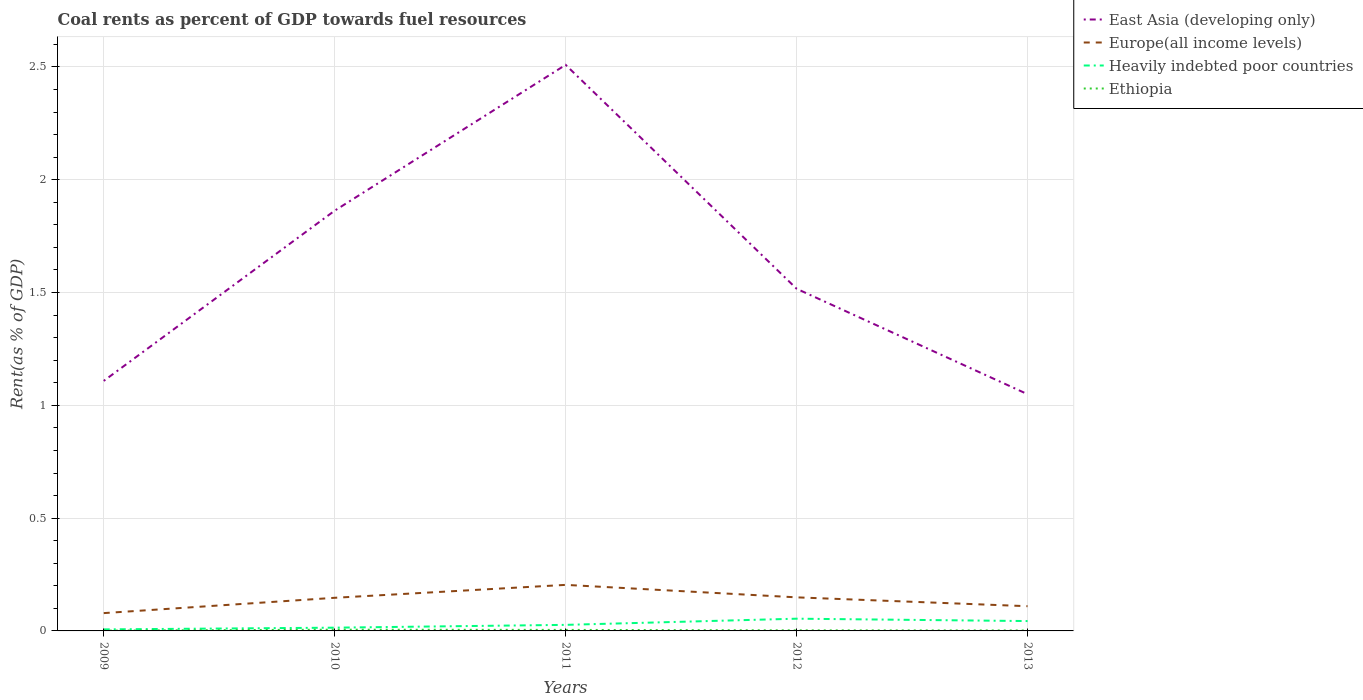Does the line corresponding to East Asia (developing only) intersect with the line corresponding to Heavily indebted poor countries?
Your answer should be compact. No. Is the number of lines equal to the number of legend labels?
Give a very brief answer. Yes. Across all years, what is the maximum coal rent in Europe(all income levels)?
Your answer should be very brief. 0.08. In which year was the coal rent in Ethiopia maximum?
Keep it short and to the point. 2009. What is the total coal rent in Europe(all income levels) in the graph?
Make the answer very short. 0.04. What is the difference between the highest and the second highest coal rent in Heavily indebted poor countries?
Offer a very short reply. 0.05. Are the values on the major ticks of Y-axis written in scientific E-notation?
Provide a succinct answer. No. How many legend labels are there?
Offer a terse response. 4. How are the legend labels stacked?
Offer a terse response. Vertical. What is the title of the graph?
Keep it short and to the point. Coal rents as percent of GDP towards fuel resources. Does "Nigeria" appear as one of the legend labels in the graph?
Ensure brevity in your answer.  No. What is the label or title of the Y-axis?
Make the answer very short. Rent(as % of GDP). What is the Rent(as % of GDP) of East Asia (developing only) in 2009?
Your answer should be compact. 1.11. What is the Rent(as % of GDP) in Europe(all income levels) in 2009?
Provide a short and direct response. 0.08. What is the Rent(as % of GDP) in Heavily indebted poor countries in 2009?
Keep it short and to the point. 0.01. What is the Rent(as % of GDP) in Ethiopia in 2009?
Your response must be concise. 0. What is the Rent(as % of GDP) in East Asia (developing only) in 2010?
Your answer should be very brief. 1.86. What is the Rent(as % of GDP) of Europe(all income levels) in 2010?
Make the answer very short. 0.15. What is the Rent(as % of GDP) of Heavily indebted poor countries in 2010?
Provide a succinct answer. 0.01. What is the Rent(as % of GDP) of Ethiopia in 2010?
Your answer should be compact. 0.01. What is the Rent(as % of GDP) in East Asia (developing only) in 2011?
Offer a terse response. 2.51. What is the Rent(as % of GDP) in Europe(all income levels) in 2011?
Offer a very short reply. 0.2. What is the Rent(as % of GDP) in Heavily indebted poor countries in 2011?
Provide a short and direct response. 0.03. What is the Rent(as % of GDP) of Ethiopia in 2011?
Ensure brevity in your answer.  0. What is the Rent(as % of GDP) of East Asia (developing only) in 2012?
Offer a very short reply. 1.52. What is the Rent(as % of GDP) of Europe(all income levels) in 2012?
Give a very brief answer. 0.15. What is the Rent(as % of GDP) in Heavily indebted poor countries in 2012?
Your answer should be very brief. 0.05. What is the Rent(as % of GDP) of Ethiopia in 2012?
Ensure brevity in your answer.  0. What is the Rent(as % of GDP) in East Asia (developing only) in 2013?
Your answer should be compact. 1.05. What is the Rent(as % of GDP) in Europe(all income levels) in 2013?
Your answer should be very brief. 0.11. What is the Rent(as % of GDP) in Heavily indebted poor countries in 2013?
Provide a short and direct response. 0.04. What is the Rent(as % of GDP) in Ethiopia in 2013?
Provide a succinct answer. 0. Across all years, what is the maximum Rent(as % of GDP) of East Asia (developing only)?
Make the answer very short. 2.51. Across all years, what is the maximum Rent(as % of GDP) in Europe(all income levels)?
Ensure brevity in your answer.  0.2. Across all years, what is the maximum Rent(as % of GDP) in Heavily indebted poor countries?
Keep it short and to the point. 0.05. Across all years, what is the maximum Rent(as % of GDP) of Ethiopia?
Ensure brevity in your answer.  0.01. Across all years, what is the minimum Rent(as % of GDP) in East Asia (developing only)?
Offer a very short reply. 1.05. Across all years, what is the minimum Rent(as % of GDP) in Europe(all income levels)?
Your answer should be compact. 0.08. Across all years, what is the minimum Rent(as % of GDP) of Heavily indebted poor countries?
Your response must be concise. 0.01. Across all years, what is the minimum Rent(as % of GDP) of Ethiopia?
Provide a succinct answer. 0. What is the total Rent(as % of GDP) in East Asia (developing only) in the graph?
Your response must be concise. 8.05. What is the total Rent(as % of GDP) of Europe(all income levels) in the graph?
Offer a very short reply. 0.69. What is the total Rent(as % of GDP) of Heavily indebted poor countries in the graph?
Your response must be concise. 0.15. What is the total Rent(as % of GDP) in Ethiopia in the graph?
Your answer should be compact. 0.02. What is the difference between the Rent(as % of GDP) of East Asia (developing only) in 2009 and that in 2010?
Your answer should be compact. -0.75. What is the difference between the Rent(as % of GDP) in Europe(all income levels) in 2009 and that in 2010?
Offer a terse response. -0.07. What is the difference between the Rent(as % of GDP) in Heavily indebted poor countries in 2009 and that in 2010?
Offer a terse response. -0.01. What is the difference between the Rent(as % of GDP) in Ethiopia in 2009 and that in 2010?
Give a very brief answer. -0. What is the difference between the Rent(as % of GDP) of East Asia (developing only) in 2009 and that in 2011?
Make the answer very short. -1.4. What is the difference between the Rent(as % of GDP) of Europe(all income levels) in 2009 and that in 2011?
Your answer should be very brief. -0.13. What is the difference between the Rent(as % of GDP) in Heavily indebted poor countries in 2009 and that in 2011?
Offer a very short reply. -0.02. What is the difference between the Rent(as % of GDP) in Ethiopia in 2009 and that in 2011?
Give a very brief answer. -0. What is the difference between the Rent(as % of GDP) of East Asia (developing only) in 2009 and that in 2012?
Provide a short and direct response. -0.41. What is the difference between the Rent(as % of GDP) in Europe(all income levels) in 2009 and that in 2012?
Give a very brief answer. -0.07. What is the difference between the Rent(as % of GDP) of Heavily indebted poor countries in 2009 and that in 2012?
Offer a terse response. -0.05. What is the difference between the Rent(as % of GDP) in Ethiopia in 2009 and that in 2012?
Provide a succinct answer. -0. What is the difference between the Rent(as % of GDP) in East Asia (developing only) in 2009 and that in 2013?
Offer a very short reply. 0.06. What is the difference between the Rent(as % of GDP) of Europe(all income levels) in 2009 and that in 2013?
Offer a terse response. -0.03. What is the difference between the Rent(as % of GDP) of Heavily indebted poor countries in 2009 and that in 2013?
Keep it short and to the point. -0.04. What is the difference between the Rent(as % of GDP) in Ethiopia in 2009 and that in 2013?
Keep it short and to the point. -0. What is the difference between the Rent(as % of GDP) in East Asia (developing only) in 2010 and that in 2011?
Offer a very short reply. -0.65. What is the difference between the Rent(as % of GDP) in Europe(all income levels) in 2010 and that in 2011?
Make the answer very short. -0.06. What is the difference between the Rent(as % of GDP) of Heavily indebted poor countries in 2010 and that in 2011?
Offer a very short reply. -0.01. What is the difference between the Rent(as % of GDP) of Ethiopia in 2010 and that in 2011?
Your answer should be very brief. 0. What is the difference between the Rent(as % of GDP) of East Asia (developing only) in 2010 and that in 2012?
Provide a succinct answer. 0.35. What is the difference between the Rent(as % of GDP) in Europe(all income levels) in 2010 and that in 2012?
Make the answer very short. -0. What is the difference between the Rent(as % of GDP) in Heavily indebted poor countries in 2010 and that in 2012?
Your response must be concise. -0.04. What is the difference between the Rent(as % of GDP) in Ethiopia in 2010 and that in 2012?
Your response must be concise. 0. What is the difference between the Rent(as % of GDP) of East Asia (developing only) in 2010 and that in 2013?
Keep it short and to the point. 0.81. What is the difference between the Rent(as % of GDP) in Europe(all income levels) in 2010 and that in 2013?
Provide a short and direct response. 0.04. What is the difference between the Rent(as % of GDP) of Heavily indebted poor countries in 2010 and that in 2013?
Your response must be concise. -0.03. What is the difference between the Rent(as % of GDP) in Ethiopia in 2010 and that in 2013?
Offer a terse response. 0. What is the difference between the Rent(as % of GDP) in Europe(all income levels) in 2011 and that in 2012?
Your answer should be very brief. 0.06. What is the difference between the Rent(as % of GDP) in Heavily indebted poor countries in 2011 and that in 2012?
Your answer should be very brief. -0.03. What is the difference between the Rent(as % of GDP) of Ethiopia in 2011 and that in 2012?
Your answer should be compact. 0. What is the difference between the Rent(as % of GDP) in East Asia (developing only) in 2011 and that in 2013?
Keep it short and to the point. 1.46. What is the difference between the Rent(as % of GDP) in Europe(all income levels) in 2011 and that in 2013?
Provide a short and direct response. 0.09. What is the difference between the Rent(as % of GDP) of Heavily indebted poor countries in 2011 and that in 2013?
Your response must be concise. -0.02. What is the difference between the Rent(as % of GDP) of Ethiopia in 2011 and that in 2013?
Offer a very short reply. 0. What is the difference between the Rent(as % of GDP) in East Asia (developing only) in 2012 and that in 2013?
Your answer should be very brief. 0.47. What is the difference between the Rent(as % of GDP) in Europe(all income levels) in 2012 and that in 2013?
Make the answer very short. 0.04. What is the difference between the Rent(as % of GDP) in Heavily indebted poor countries in 2012 and that in 2013?
Provide a succinct answer. 0.01. What is the difference between the Rent(as % of GDP) of East Asia (developing only) in 2009 and the Rent(as % of GDP) of Europe(all income levels) in 2010?
Make the answer very short. 0.96. What is the difference between the Rent(as % of GDP) in East Asia (developing only) in 2009 and the Rent(as % of GDP) in Heavily indebted poor countries in 2010?
Your answer should be very brief. 1.09. What is the difference between the Rent(as % of GDP) in East Asia (developing only) in 2009 and the Rent(as % of GDP) in Ethiopia in 2010?
Offer a very short reply. 1.1. What is the difference between the Rent(as % of GDP) in Europe(all income levels) in 2009 and the Rent(as % of GDP) in Heavily indebted poor countries in 2010?
Keep it short and to the point. 0.06. What is the difference between the Rent(as % of GDP) in Europe(all income levels) in 2009 and the Rent(as % of GDP) in Ethiopia in 2010?
Your answer should be compact. 0.07. What is the difference between the Rent(as % of GDP) in Heavily indebted poor countries in 2009 and the Rent(as % of GDP) in Ethiopia in 2010?
Provide a succinct answer. 0. What is the difference between the Rent(as % of GDP) in East Asia (developing only) in 2009 and the Rent(as % of GDP) in Europe(all income levels) in 2011?
Your response must be concise. 0.9. What is the difference between the Rent(as % of GDP) of East Asia (developing only) in 2009 and the Rent(as % of GDP) of Heavily indebted poor countries in 2011?
Provide a short and direct response. 1.08. What is the difference between the Rent(as % of GDP) in East Asia (developing only) in 2009 and the Rent(as % of GDP) in Ethiopia in 2011?
Make the answer very short. 1.1. What is the difference between the Rent(as % of GDP) in Europe(all income levels) in 2009 and the Rent(as % of GDP) in Heavily indebted poor countries in 2011?
Give a very brief answer. 0.05. What is the difference between the Rent(as % of GDP) of Europe(all income levels) in 2009 and the Rent(as % of GDP) of Ethiopia in 2011?
Your answer should be very brief. 0.07. What is the difference between the Rent(as % of GDP) of Heavily indebted poor countries in 2009 and the Rent(as % of GDP) of Ethiopia in 2011?
Ensure brevity in your answer.  0. What is the difference between the Rent(as % of GDP) in East Asia (developing only) in 2009 and the Rent(as % of GDP) in Europe(all income levels) in 2012?
Your answer should be very brief. 0.96. What is the difference between the Rent(as % of GDP) in East Asia (developing only) in 2009 and the Rent(as % of GDP) in Heavily indebted poor countries in 2012?
Your answer should be very brief. 1.05. What is the difference between the Rent(as % of GDP) of East Asia (developing only) in 2009 and the Rent(as % of GDP) of Ethiopia in 2012?
Offer a terse response. 1.11. What is the difference between the Rent(as % of GDP) in Europe(all income levels) in 2009 and the Rent(as % of GDP) in Heavily indebted poor countries in 2012?
Give a very brief answer. 0.02. What is the difference between the Rent(as % of GDP) in Europe(all income levels) in 2009 and the Rent(as % of GDP) in Ethiopia in 2012?
Offer a very short reply. 0.08. What is the difference between the Rent(as % of GDP) in Heavily indebted poor countries in 2009 and the Rent(as % of GDP) in Ethiopia in 2012?
Your response must be concise. 0. What is the difference between the Rent(as % of GDP) in East Asia (developing only) in 2009 and the Rent(as % of GDP) in Heavily indebted poor countries in 2013?
Give a very brief answer. 1.06. What is the difference between the Rent(as % of GDP) in East Asia (developing only) in 2009 and the Rent(as % of GDP) in Ethiopia in 2013?
Provide a short and direct response. 1.11. What is the difference between the Rent(as % of GDP) in Europe(all income levels) in 2009 and the Rent(as % of GDP) in Heavily indebted poor countries in 2013?
Ensure brevity in your answer.  0.04. What is the difference between the Rent(as % of GDP) of Europe(all income levels) in 2009 and the Rent(as % of GDP) of Ethiopia in 2013?
Ensure brevity in your answer.  0.08. What is the difference between the Rent(as % of GDP) in Heavily indebted poor countries in 2009 and the Rent(as % of GDP) in Ethiopia in 2013?
Provide a succinct answer. 0. What is the difference between the Rent(as % of GDP) in East Asia (developing only) in 2010 and the Rent(as % of GDP) in Europe(all income levels) in 2011?
Make the answer very short. 1.66. What is the difference between the Rent(as % of GDP) of East Asia (developing only) in 2010 and the Rent(as % of GDP) of Heavily indebted poor countries in 2011?
Keep it short and to the point. 1.84. What is the difference between the Rent(as % of GDP) of East Asia (developing only) in 2010 and the Rent(as % of GDP) of Ethiopia in 2011?
Keep it short and to the point. 1.86. What is the difference between the Rent(as % of GDP) in Europe(all income levels) in 2010 and the Rent(as % of GDP) in Heavily indebted poor countries in 2011?
Provide a short and direct response. 0.12. What is the difference between the Rent(as % of GDP) in Europe(all income levels) in 2010 and the Rent(as % of GDP) in Ethiopia in 2011?
Provide a succinct answer. 0.14. What is the difference between the Rent(as % of GDP) in Heavily indebted poor countries in 2010 and the Rent(as % of GDP) in Ethiopia in 2011?
Keep it short and to the point. 0.01. What is the difference between the Rent(as % of GDP) of East Asia (developing only) in 2010 and the Rent(as % of GDP) of Europe(all income levels) in 2012?
Offer a very short reply. 1.71. What is the difference between the Rent(as % of GDP) of East Asia (developing only) in 2010 and the Rent(as % of GDP) of Heavily indebted poor countries in 2012?
Give a very brief answer. 1.81. What is the difference between the Rent(as % of GDP) in East Asia (developing only) in 2010 and the Rent(as % of GDP) in Ethiopia in 2012?
Offer a terse response. 1.86. What is the difference between the Rent(as % of GDP) in Europe(all income levels) in 2010 and the Rent(as % of GDP) in Heavily indebted poor countries in 2012?
Offer a terse response. 0.09. What is the difference between the Rent(as % of GDP) of Europe(all income levels) in 2010 and the Rent(as % of GDP) of Ethiopia in 2012?
Offer a very short reply. 0.14. What is the difference between the Rent(as % of GDP) in Heavily indebted poor countries in 2010 and the Rent(as % of GDP) in Ethiopia in 2012?
Give a very brief answer. 0.01. What is the difference between the Rent(as % of GDP) in East Asia (developing only) in 2010 and the Rent(as % of GDP) in Europe(all income levels) in 2013?
Offer a very short reply. 1.75. What is the difference between the Rent(as % of GDP) in East Asia (developing only) in 2010 and the Rent(as % of GDP) in Heavily indebted poor countries in 2013?
Provide a succinct answer. 1.82. What is the difference between the Rent(as % of GDP) of East Asia (developing only) in 2010 and the Rent(as % of GDP) of Ethiopia in 2013?
Ensure brevity in your answer.  1.86. What is the difference between the Rent(as % of GDP) of Europe(all income levels) in 2010 and the Rent(as % of GDP) of Heavily indebted poor countries in 2013?
Keep it short and to the point. 0.1. What is the difference between the Rent(as % of GDP) in Europe(all income levels) in 2010 and the Rent(as % of GDP) in Ethiopia in 2013?
Your response must be concise. 0.14. What is the difference between the Rent(as % of GDP) of Heavily indebted poor countries in 2010 and the Rent(as % of GDP) of Ethiopia in 2013?
Provide a succinct answer. 0.01. What is the difference between the Rent(as % of GDP) of East Asia (developing only) in 2011 and the Rent(as % of GDP) of Europe(all income levels) in 2012?
Give a very brief answer. 2.36. What is the difference between the Rent(as % of GDP) of East Asia (developing only) in 2011 and the Rent(as % of GDP) of Heavily indebted poor countries in 2012?
Keep it short and to the point. 2.45. What is the difference between the Rent(as % of GDP) in East Asia (developing only) in 2011 and the Rent(as % of GDP) in Ethiopia in 2012?
Ensure brevity in your answer.  2.51. What is the difference between the Rent(as % of GDP) in Europe(all income levels) in 2011 and the Rent(as % of GDP) in Heavily indebted poor countries in 2012?
Your answer should be compact. 0.15. What is the difference between the Rent(as % of GDP) in Europe(all income levels) in 2011 and the Rent(as % of GDP) in Ethiopia in 2012?
Provide a succinct answer. 0.2. What is the difference between the Rent(as % of GDP) in Heavily indebted poor countries in 2011 and the Rent(as % of GDP) in Ethiopia in 2012?
Provide a short and direct response. 0.02. What is the difference between the Rent(as % of GDP) of East Asia (developing only) in 2011 and the Rent(as % of GDP) of Europe(all income levels) in 2013?
Your answer should be compact. 2.4. What is the difference between the Rent(as % of GDP) in East Asia (developing only) in 2011 and the Rent(as % of GDP) in Heavily indebted poor countries in 2013?
Your answer should be compact. 2.47. What is the difference between the Rent(as % of GDP) in East Asia (developing only) in 2011 and the Rent(as % of GDP) in Ethiopia in 2013?
Ensure brevity in your answer.  2.51. What is the difference between the Rent(as % of GDP) in Europe(all income levels) in 2011 and the Rent(as % of GDP) in Heavily indebted poor countries in 2013?
Provide a succinct answer. 0.16. What is the difference between the Rent(as % of GDP) of Europe(all income levels) in 2011 and the Rent(as % of GDP) of Ethiopia in 2013?
Provide a succinct answer. 0.2. What is the difference between the Rent(as % of GDP) of Heavily indebted poor countries in 2011 and the Rent(as % of GDP) of Ethiopia in 2013?
Give a very brief answer. 0.02. What is the difference between the Rent(as % of GDP) of East Asia (developing only) in 2012 and the Rent(as % of GDP) of Europe(all income levels) in 2013?
Provide a succinct answer. 1.41. What is the difference between the Rent(as % of GDP) in East Asia (developing only) in 2012 and the Rent(as % of GDP) in Heavily indebted poor countries in 2013?
Keep it short and to the point. 1.47. What is the difference between the Rent(as % of GDP) of East Asia (developing only) in 2012 and the Rent(as % of GDP) of Ethiopia in 2013?
Offer a terse response. 1.51. What is the difference between the Rent(as % of GDP) of Europe(all income levels) in 2012 and the Rent(as % of GDP) of Heavily indebted poor countries in 2013?
Your response must be concise. 0.11. What is the difference between the Rent(as % of GDP) of Europe(all income levels) in 2012 and the Rent(as % of GDP) of Ethiopia in 2013?
Ensure brevity in your answer.  0.15. What is the difference between the Rent(as % of GDP) in Heavily indebted poor countries in 2012 and the Rent(as % of GDP) in Ethiopia in 2013?
Offer a very short reply. 0.05. What is the average Rent(as % of GDP) in East Asia (developing only) per year?
Give a very brief answer. 1.61. What is the average Rent(as % of GDP) of Europe(all income levels) per year?
Keep it short and to the point. 0.14. What is the average Rent(as % of GDP) in Heavily indebted poor countries per year?
Provide a succinct answer. 0.03. What is the average Rent(as % of GDP) in Ethiopia per year?
Keep it short and to the point. 0. In the year 2009, what is the difference between the Rent(as % of GDP) in East Asia (developing only) and Rent(as % of GDP) in Europe(all income levels)?
Your answer should be compact. 1.03. In the year 2009, what is the difference between the Rent(as % of GDP) in East Asia (developing only) and Rent(as % of GDP) in Heavily indebted poor countries?
Your answer should be compact. 1.1. In the year 2009, what is the difference between the Rent(as % of GDP) of East Asia (developing only) and Rent(as % of GDP) of Ethiopia?
Keep it short and to the point. 1.11. In the year 2009, what is the difference between the Rent(as % of GDP) of Europe(all income levels) and Rent(as % of GDP) of Heavily indebted poor countries?
Your response must be concise. 0.07. In the year 2009, what is the difference between the Rent(as % of GDP) in Europe(all income levels) and Rent(as % of GDP) in Ethiopia?
Offer a very short reply. 0.08. In the year 2009, what is the difference between the Rent(as % of GDP) in Heavily indebted poor countries and Rent(as % of GDP) in Ethiopia?
Provide a succinct answer. 0.01. In the year 2010, what is the difference between the Rent(as % of GDP) of East Asia (developing only) and Rent(as % of GDP) of Europe(all income levels)?
Make the answer very short. 1.72. In the year 2010, what is the difference between the Rent(as % of GDP) of East Asia (developing only) and Rent(as % of GDP) of Heavily indebted poor countries?
Your response must be concise. 1.85. In the year 2010, what is the difference between the Rent(as % of GDP) in East Asia (developing only) and Rent(as % of GDP) in Ethiopia?
Offer a terse response. 1.86. In the year 2010, what is the difference between the Rent(as % of GDP) of Europe(all income levels) and Rent(as % of GDP) of Heavily indebted poor countries?
Your response must be concise. 0.13. In the year 2010, what is the difference between the Rent(as % of GDP) in Europe(all income levels) and Rent(as % of GDP) in Ethiopia?
Offer a terse response. 0.14. In the year 2010, what is the difference between the Rent(as % of GDP) in Heavily indebted poor countries and Rent(as % of GDP) in Ethiopia?
Provide a short and direct response. 0.01. In the year 2011, what is the difference between the Rent(as % of GDP) in East Asia (developing only) and Rent(as % of GDP) in Europe(all income levels)?
Ensure brevity in your answer.  2.31. In the year 2011, what is the difference between the Rent(as % of GDP) of East Asia (developing only) and Rent(as % of GDP) of Heavily indebted poor countries?
Offer a very short reply. 2.48. In the year 2011, what is the difference between the Rent(as % of GDP) of East Asia (developing only) and Rent(as % of GDP) of Ethiopia?
Make the answer very short. 2.5. In the year 2011, what is the difference between the Rent(as % of GDP) of Europe(all income levels) and Rent(as % of GDP) of Heavily indebted poor countries?
Keep it short and to the point. 0.18. In the year 2011, what is the difference between the Rent(as % of GDP) of Europe(all income levels) and Rent(as % of GDP) of Ethiopia?
Offer a terse response. 0.2. In the year 2011, what is the difference between the Rent(as % of GDP) in Heavily indebted poor countries and Rent(as % of GDP) in Ethiopia?
Make the answer very short. 0.02. In the year 2012, what is the difference between the Rent(as % of GDP) in East Asia (developing only) and Rent(as % of GDP) in Europe(all income levels)?
Make the answer very short. 1.37. In the year 2012, what is the difference between the Rent(as % of GDP) of East Asia (developing only) and Rent(as % of GDP) of Heavily indebted poor countries?
Provide a short and direct response. 1.46. In the year 2012, what is the difference between the Rent(as % of GDP) of East Asia (developing only) and Rent(as % of GDP) of Ethiopia?
Ensure brevity in your answer.  1.51. In the year 2012, what is the difference between the Rent(as % of GDP) of Europe(all income levels) and Rent(as % of GDP) of Heavily indebted poor countries?
Your response must be concise. 0.09. In the year 2012, what is the difference between the Rent(as % of GDP) in Europe(all income levels) and Rent(as % of GDP) in Ethiopia?
Keep it short and to the point. 0.15. In the year 2012, what is the difference between the Rent(as % of GDP) of Heavily indebted poor countries and Rent(as % of GDP) of Ethiopia?
Keep it short and to the point. 0.05. In the year 2013, what is the difference between the Rent(as % of GDP) in East Asia (developing only) and Rent(as % of GDP) in Europe(all income levels)?
Provide a succinct answer. 0.94. In the year 2013, what is the difference between the Rent(as % of GDP) in East Asia (developing only) and Rent(as % of GDP) in Heavily indebted poor countries?
Provide a short and direct response. 1.01. In the year 2013, what is the difference between the Rent(as % of GDP) of East Asia (developing only) and Rent(as % of GDP) of Ethiopia?
Your answer should be very brief. 1.05. In the year 2013, what is the difference between the Rent(as % of GDP) in Europe(all income levels) and Rent(as % of GDP) in Heavily indebted poor countries?
Make the answer very short. 0.07. In the year 2013, what is the difference between the Rent(as % of GDP) of Europe(all income levels) and Rent(as % of GDP) of Ethiopia?
Provide a succinct answer. 0.11. In the year 2013, what is the difference between the Rent(as % of GDP) in Heavily indebted poor countries and Rent(as % of GDP) in Ethiopia?
Keep it short and to the point. 0.04. What is the ratio of the Rent(as % of GDP) of East Asia (developing only) in 2009 to that in 2010?
Keep it short and to the point. 0.59. What is the ratio of the Rent(as % of GDP) in Europe(all income levels) in 2009 to that in 2010?
Provide a succinct answer. 0.54. What is the ratio of the Rent(as % of GDP) of Heavily indebted poor countries in 2009 to that in 2010?
Your response must be concise. 0.47. What is the ratio of the Rent(as % of GDP) in Ethiopia in 2009 to that in 2010?
Ensure brevity in your answer.  0.24. What is the ratio of the Rent(as % of GDP) in East Asia (developing only) in 2009 to that in 2011?
Provide a short and direct response. 0.44. What is the ratio of the Rent(as % of GDP) of Europe(all income levels) in 2009 to that in 2011?
Give a very brief answer. 0.39. What is the ratio of the Rent(as % of GDP) of Heavily indebted poor countries in 2009 to that in 2011?
Give a very brief answer. 0.25. What is the ratio of the Rent(as % of GDP) in Ethiopia in 2009 to that in 2011?
Give a very brief answer. 0.29. What is the ratio of the Rent(as % of GDP) in East Asia (developing only) in 2009 to that in 2012?
Provide a short and direct response. 0.73. What is the ratio of the Rent(as % of GDP) in Europe(all income levels) in 2009 to that in 2012?
Your answer should be very brief. 0.53. What is the ratio of the Rent(as % of GDP) of Heavily indebted poor countries in 2009 to that in 2012?
Ensure brevity in your answer.  0.13. What is the ratio of the Rent(as % of GDP) in Ethiopia in 2009 to that in 2012?
Your answer should be very brief. 0.51. What is the ratio of the Rent(as % of GDP) of East Asia (developing only) in 2009 to that in 2013?
Keep it short and to the point. 1.06. What is the ratio of the Rent(as % of GDP) in Europe(all income levels) in 2009 to that in 2013?
Keep it short and to the point. 0.72. What is the ratio of the Rent(as % of GDP) in Heavily indebted poor countries in 2009 to that in 2013?
Offer a terse response. 0.16. What is the ratio of the Rent(as % of GDP) in Ethiopia in 2009 to that in 2013?
Keep it short and to the point. 0.63. What is the ratio of the Rent(as % of GDP) of East Asia (developing only) in 2010 to that in 2011?
Provide a succinct answer. 0.74. What is the ratio of the Rent(as % of GDP) in Europe(all income levels) in 2010 to that in 2011?
Give a very brief answer. 0.72. What is the ratio of the Rent(as % of GDP) in Heavily indebted poor countries in 2010 to that in 2011?
Make the answer very short. 0.54. What is the ratio of the Rent(as % of GDP) of Ethiopia in 2010 to that in 2011?
Offer a very short reply. 1.23. What is the ratio of the Rent(as % of GDP) in East Asia (developing only) in 2010 to that in 2012?
Offer a very short reply. 1.23. What is the ratio of the Rent(as % of GDP) of Europe(all income levels) in 2010 to that in 2012?
Your response must be concise. 0.99. What is the ratio of the Rent(as % of GDP) of Heavily indebted poor countries in 2010 to that in 2012?
Provide a succinct answer. 0.27. What is the ratio of the Rent(as % of GDP) in Ethiopia in 2010 to that in 2012?
Your answer should be very brief. 2.16. What is the ratio of the Rent(as % of GDP) of East Asia (developing only) in 2010 to that in 2013?
Your answer should be very brief. 1.78. What is the ratio of the Rent(as % of GDP) of Europe(all income levels) in 2010 to that in 2013?
Ensure brevity in your answer.  1.34. What is the ratio of the Rent(as % of GDP) in Heavily indebted poor countries in 2010 to that in 2013?
Your response must be concise. 0.33. What is the ratio of the Rent(as % of GDP) of Ethiopia in 2010 to that in 2013?
Your answer should be compact. 2.66. What is the ratio of the Rent(as % of GDP) of East Asia (developing only) in 2011 to that in 2012?
Your response must be concise. 1.65. What is the ratio of the Rent(as % of GDP) in Europe(all income levels) in 2011 to that in 2012?
Your answer should be compact. 1.37. What is the ratio of the Rent(as % of GDP) of Heavily indebted poor countries in 2011 to that in 2012?
Provide a succinct answer. 0.5. What is the ratio of the Rent(as % of GDP) of Ethiopia in 2011 to that in 2012?
Make the answer very short. 1.76. What is the ratio of the Rent(as % of GDP) of East Asia (developing only) in 2011 to that in 2013?
Keep it short and to the point. 2.39. What is the ratio of the Rent(as % of GDP) of Europe(all income levels) in 2011 to that in 2013?
Offer a very short reply. 1.86. What is the ratio of the Rent(as % of GDP) of Heavily indebted poor countries in 2011 to that in 2013?
Ensure brevity in your answer.  0.61. What is the ratio of the Rent(as % of GDP) in Ethiopia in 2011 to that in 2013?
Keep it short and to the point. 2.17. What is the ratio of the Rent(as % of GDP) in East Asia (developing only) in 2012 to that in 2013?
Provide a short and direct response. 1.45. What is the ratio of the Rent(as % of GDP) in Europe(all income levels) in 2012 to that in 2013?
Provide a succinct answer. 1.36. What is the ratio of the Rent(as % of GDP) of Heavily indebted poor countries in 2012 to that in 2013?
Provide a succinct answer. 1.24. What is the ratio of the Rent(as % of GDP) in Ethiopia in 2012 to that in 2013?
Provide a short and direct response. 1.23. What is the difference between the highest and the second highest Rent(as % of GDP) of East Asia (developing only)?
Ensure brevity in your answer.  0.65. What is the difference between the highest and the second highest Rent(as % of GDP) in Europe(all income levels)?
Keep it short and to the point. 0.06. What is the difference between the highest and the second highest Rent(as % of GDP) in Heavily indebted poor countries?
Keep it short and to the point. 0.01. What is the difference between the highest and the second highest Rent(as % of GDP) of Ethiopia?
Ensure brevity in your answer.  0. What is the difference between the highest and the lowest Rent(as % of GDP) of East Asia (developing only)?
Keep it short and to the point. 1.46. What is the difference between the highest and the lowest Rent(as % of GDP) of Europe(all income levels)?
Keep it short and to the point. 0.13. What is the difference between the highest and the lowest Rent(as % of GDP) of Heavily indebted poor countries?
Offer a terse response. 0.05. What is the difference between the highest and the lowest Rent(as % of GDP) in Ethiopia?
Keep it short and to the point. 0. 